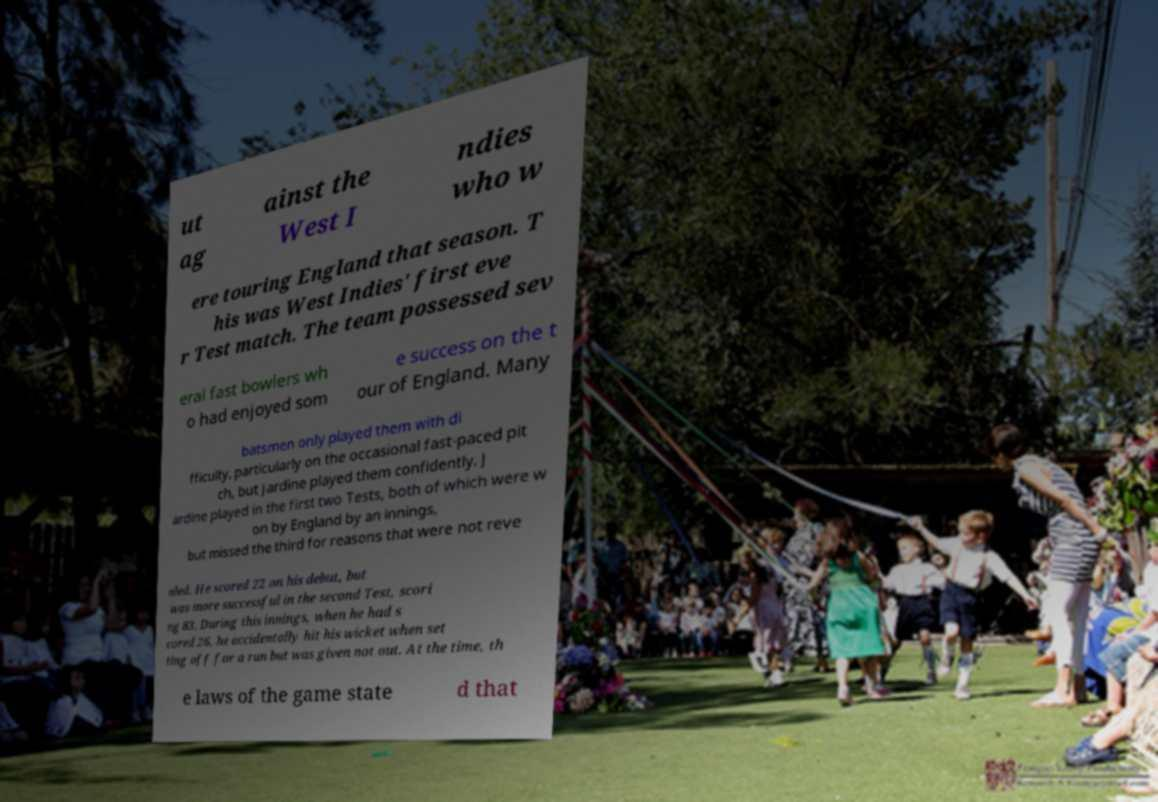For documentation purposes, I need the text within this image transcribed. Could you provide that? ut ag ainst the West I ndies who w ere touring England that season. T his was West Indies' first eve r Test match. The team possessed sev eral fast bowlers wh o had enjoyed som e success on the t our of England. Many batsmen only played them with di fficulty, particularly on the occasional fast-paced pit ch, but Jardine played them confidently. J ardine played in the first two Tests, both of which were w on by England by an innings, but missed the third for reasons that were not reve aled. He scored 22 on his debut, but was more successful in the second Test, scori ng 83. During this innings, when he had s cored 26, he accidentally hit his wicket when set ting off for a run but was given not out. At the time, th e laws of the game state d that 